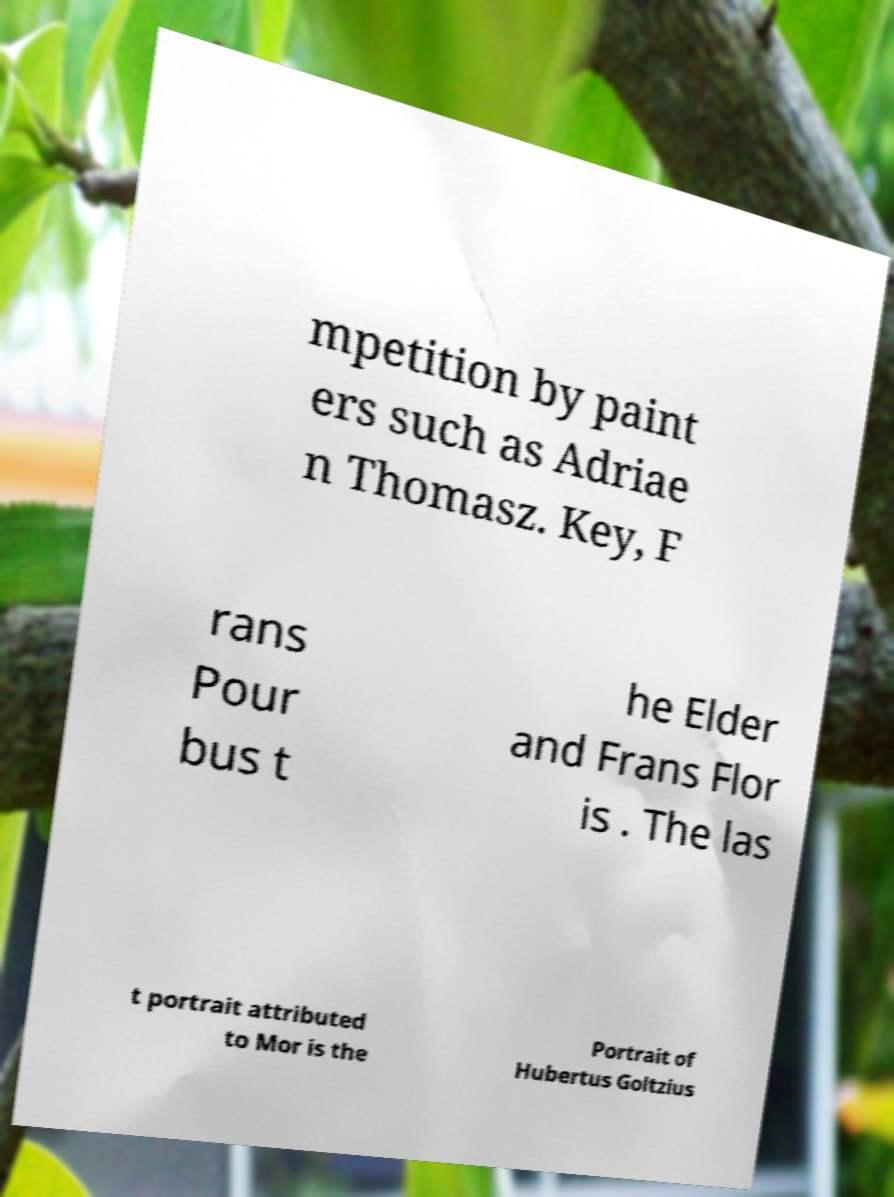I need the written content from this picture converted into text. Can you do that? mpetition by paint ers such as Adriae n Thomasz. Key, F rans Pour bus t he Elder and Frans Flor is . The las t portrait attributed to Mor is the Portrait of Hubertus Goltzius 